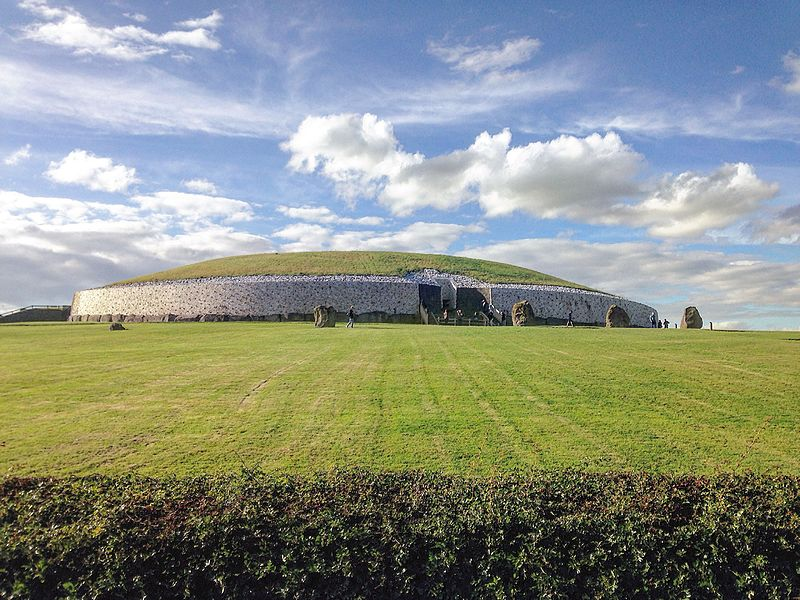Can you explain the significance of the standing stones around Newgrange? The standing stones around Newgrange are believed to have astronomical and ceremonial significance, possibly serving as ancient landmarks for calendrical or ritual functions. They form part of a wider complex known in archaeology as 'megalithic art', often associated with astronomical events and seasons, which highlights the sophisticated understanding of astronomy by the Neolithic builders. 